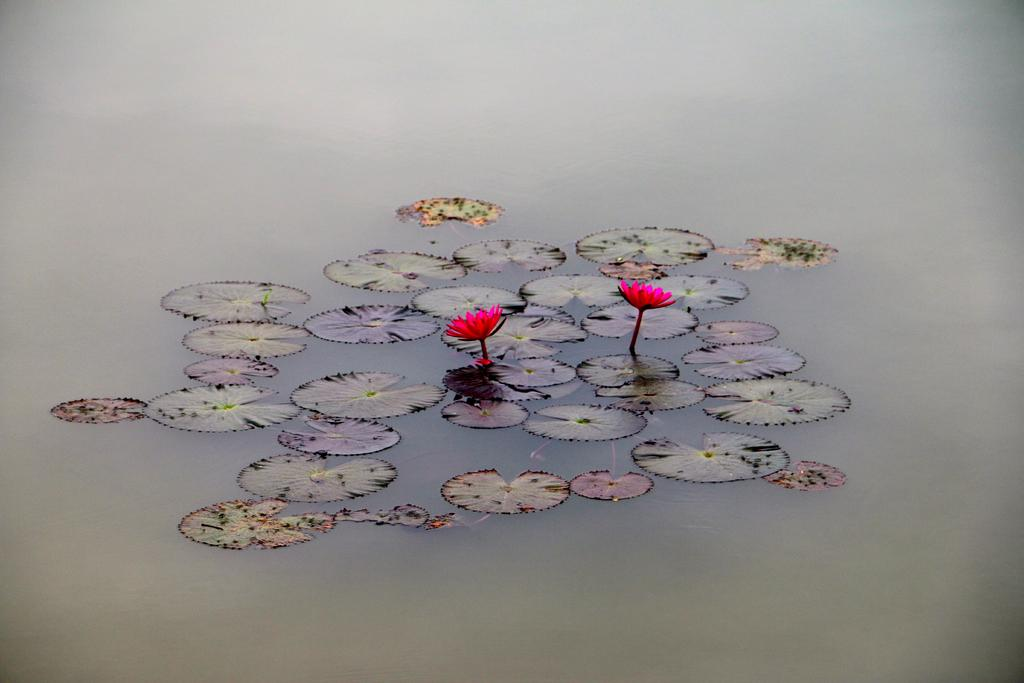How many flowers are present in the image? There are two flowers in the image. What other elements can be seen in the image besides the flowers? There are leaves in the image. Where are the flowers and leaves located in the image? The flowers and leaves are in the water. Can you tell me how many pages are visible in the image? There are no pages present in the image; it features two flowers and leaves in the water. Is there a bike or skate visible in the image? No, there is no bike or skate present in the image. 